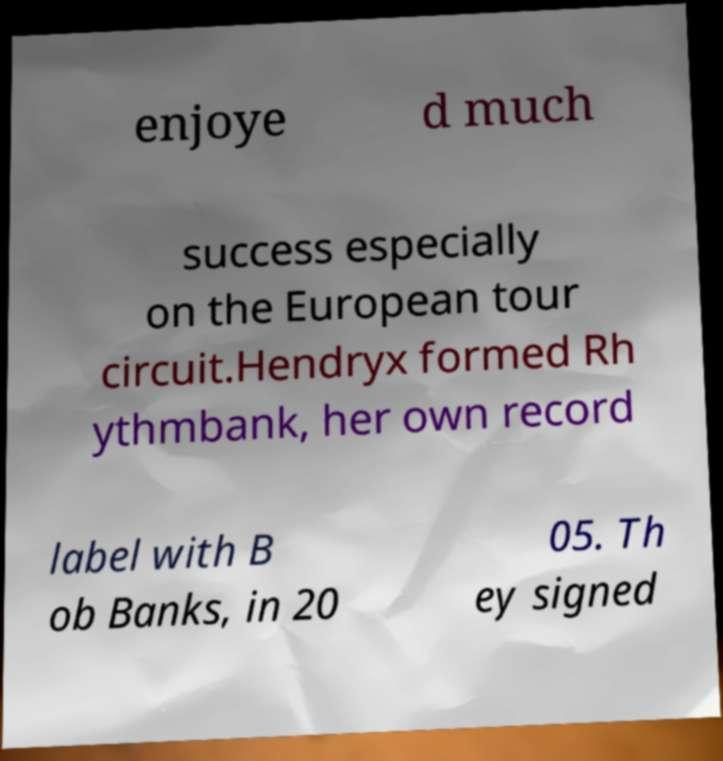I need the written content from this picture converted into text. Can you do that? enjoye d much success especially on the European tour circuit.Hendryx formed Rh ythmbank, her own record label with B ob Banks, in 20 05. Th ey signed 